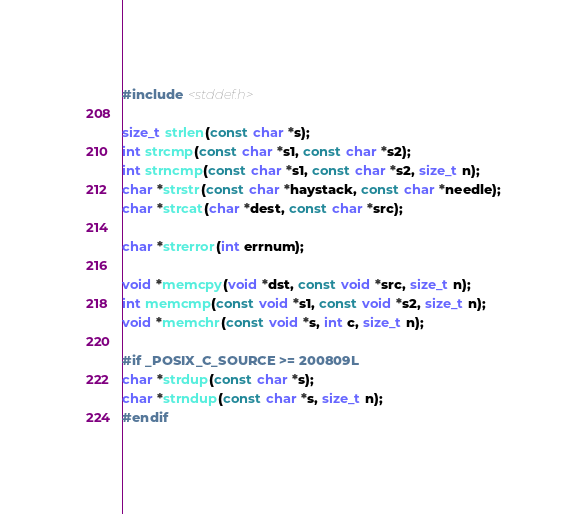<code> <loc_0><loc_0><loc_500><loc_500><_C_>#include <stddef.h>

size_t strlen(const char *s);
int strcmp(const char *s1, const char *s2);
int strncmp(const char *s1, const char *s2, size_t n);
char *strstr(const char *haystack, const char *needle);
char *strcat(char *dest, const char *src);

char *strerror(int errnum);

void *memcpy(void *dst, const void *src, size_t n);
int memcmp(const void *s1, const void *s2, size_t n);
void *memchr(const void *s, int c, size_t n);

#if _POSIX_C_SOURCE >= 200809L
char *strdup(const char *s);
char *strndup(const char *s, size_t n);
#endif
</code> 